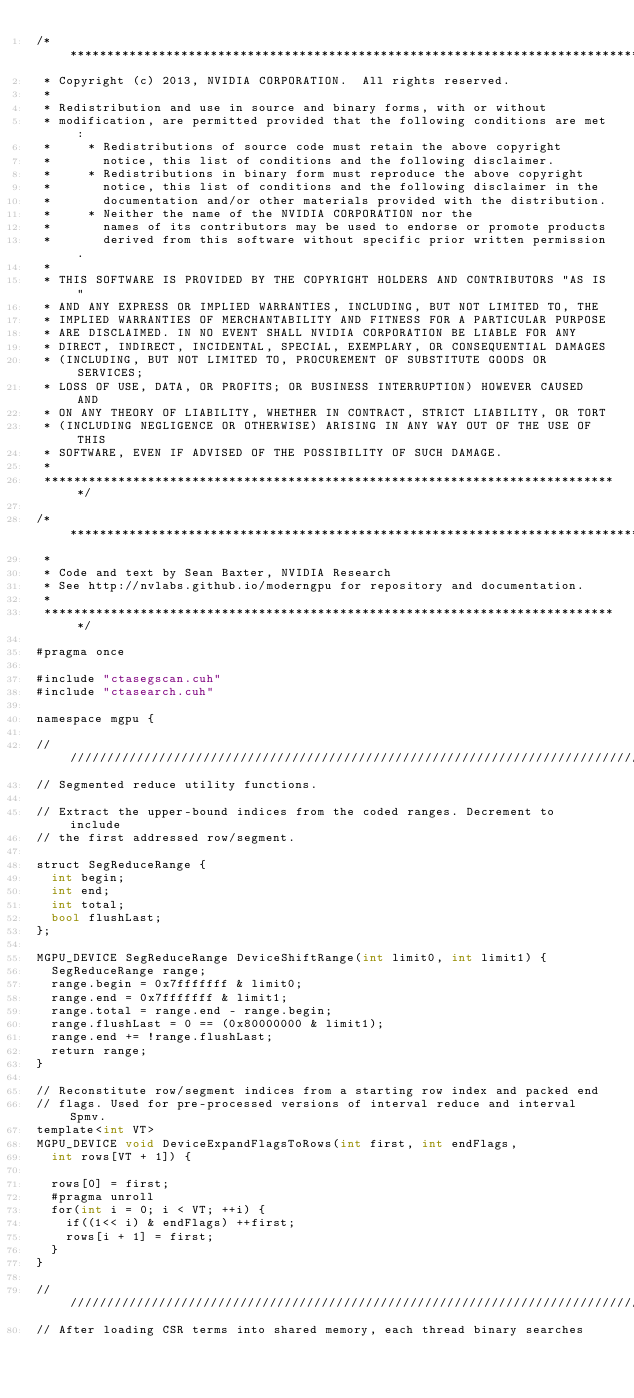<code> <loc_0><loc_0><loc_500><loc_500><_Cuda_>/******************************************************************************
 * Copyright (c) 2013, NVIDIA CORPORATION.  All rights reserved.
 *
 * Redistribution and use in source and binary forms, with or without
 * modification, are permitted provided that the following conditions are met:
 *     * Redistributions of source code must retain the above copyright
 *       notice, this list of conditions and the following disclaimer.
 *     * Redistributions in binary form must reproduce the above copyright
 *       notice, this list of conditions and the following disclaimer in the
 *       documentation and/or other materials provided with the distribution.
 *     * Neither the name of the NVIDIA CORPORATION nor the
 *       names of its contributors may be used to endorse or promote products
 *       derived from this software without specific prior written permission.
 *
 * THIS SOFTWARE IS PROVIDED BY THE COPYRIGHT HOLDERS AND CONTRIBUTORS "AS IS"
 * AND ANY EXPRESS OR IMPLIED WARRANTIES, INCLUDING, BUT NOT LIMITED TO, THE
 * IMPLIED WARRANTIES OF MERCHANTABILITY AND FITNESS FOR A PARTICULAR PURPOSE
 * ARE DISCLAIMED. IN NO EVENT SHALL NVIDIA CORPORATION BE LIABLE FOR ANY
 * DIRECT, INDIRECT, INCIDENTAL, SPECIAL, EXEMPLARY, OR CONSEQUENTIAL DAMAGES
 * (INCLUDING, BUT NOT LIMITED TO, PROCUREMENT OF SUBSTITUTE GOODS OR SERVICES;
 * LOSS OF USE, DATA, OR PROFITS; OR BUSINESS INTERRUPTION) HOWEVER CAUSED AND
 * ON ANY THEORY OF LIABILITY, WHETHER IN CONTRACT, STRICT LIABILITY, OR TORT
 * (INCLUDING NEGLIGENCE OR OTHERWISE) ARISING IN ANY WAY OUT OF THE USE OF THIS
 * SOFTWARE, EVEN IF ADVISED OF THE POSSIBILITY OF SUCH DAMAGE.
 *
 ******************************************************************************/

/******************************************************************************
 *
 * Code and text by Sean Baxter, NVIDIA Research
 * See http://nvlabs.github.io/moderngpu for repository and documentation.
 *
 ******************************************************************************/

#pragma once

#include "ctasegscan.cuh"
#include "ctasearch.cuh"

namespace mgpu {

////////////////////////////////////////////////////////////////////////////////
// Segmented reduce utility functions.

// Extract the upper-bound indices from the coded ranges. Decrement to include
// the first addressed row/segment.

struct SegReduceRange {
	int begin;
	int end;
	int total;
	bool flushLast;
};

MGPU_DEVICE SegReduceRange DeviceShiftRange(int limit0, int limit1) {
	SegReduceRange range;
	range.begin = 0x7fffffff & limit0;
	range.end = 0x7fffffff & limit1;
	range.total = range.end - range.begin;
	range.flushLast = 0 == (0x80000000 & limit1);
	range.end += !range.flushLast;
	return range;
}

// Reconstitute row/segment indices from a starting row index and packed end
// flags. Used for pre-processed versions of interval reduce and interval Spmv.
template<int VT>
MGPU_DEVICE void DeviceExpandFlagsToRows(int first, int endFlags,
	int rows[VT + 1]) {

	rows[0] = first;
	#pragma unroll
	for(int i = 0; i < VT; ++i) {
		if((1<< i) & endFlags) ++first;
		rows[i + 1] = first;
	}
}

////////////////////////////////////////////////////////////////////////////////
// After loading CSR terms into shared memory, each thread binary searches</code> 